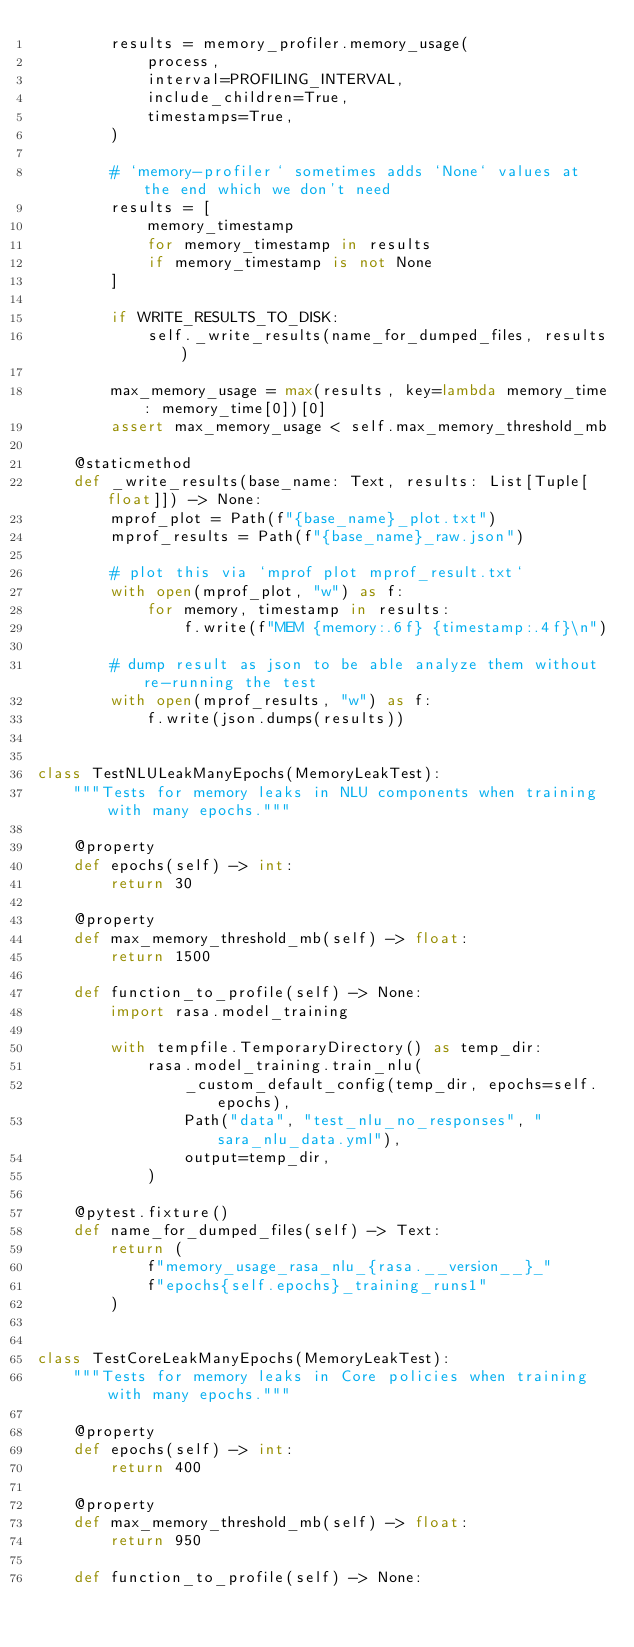Convert code to text. <code><loc_0><loc_0><loc_500><loc_500><_Python_>        results = memory_profiler.memory_usage(
            process,
            interval=PROFILING_INTERVAL,
            include_children=True,
            timestamps=True,
        )

        # `memory-profiler` sometimes adds `None` values at the end which we don't need
        results = [
            memory_timestamp
            for memory_timestamp in results
            if memory_timestamp is not None
        ]

        if WRITE_RESULTS_TO_DISK:
            self._write_results(name_for_dumped_files, results)

        max_memory_usage = max(results, key=lambda memory_time: memory_time[0])[0]
        assert max_memory_usage < self.max_memory_threshold_mb

    @staticmethod
    def _write_results(base_name: Text, results: List[Tuple[float]]) -> None:
        mprof_plot = Path(f"{base_name}_plot.txt")
        mprof_results = Path(f"{base_name}_raw.json")

        # plot this via `mprof plot mprof_result.txt`
        with open(mprof_plot, "w") as f:
            for memory, timestamp in results:
                f.write(f"MEM {memory:.6f} {timestamp:.4f}\n")

        # dump result as json to be able analyze them without re-running the test
        with open(mprof_results, "w") as f:
            f.write(json.dumps(results))


class TestNLULeakManyEpochs(MemoryLeakTest):
    """Tests for memory leaks in NLU components when training with many epochs."""

    @property
    def epochs(self) -> int:
        return 30

    @property
    def max_memory_threshold_mb(self) -> float:
        return 1500

    def function_to_profile(self) -> None:
        import rasa.model_training

        with tempfile.TemporaryDirectory() as temp_dir:
            rasa.model_training.train_nlu(
                _custom_default_config(temp_dir, epochs=self.epochs),
                Path("data", "test_nlu_no_responses", "sara_nlu_data.yml"),
                output=temp_dir,
            )

    @pytest.fixture()
    def name_for_dumped_files(self) -> Text:
        return (
            f"memory_usage_rasa_nlu_{rasa.__version__}_"
            f"epochs{self.epochs}_training_runs1"
        )


class TestCoreLeakManyEpochs(MemoryLeakTest):
    """Tests for memory leaks in Core policies when training with many epochs."""

    @property
    def epochs(self) -> int:
        return 400

    @property
    def max_memory_threshold_mb(self) -> float:
        return 950

    def function_to_profile(self) -> None:</code> 